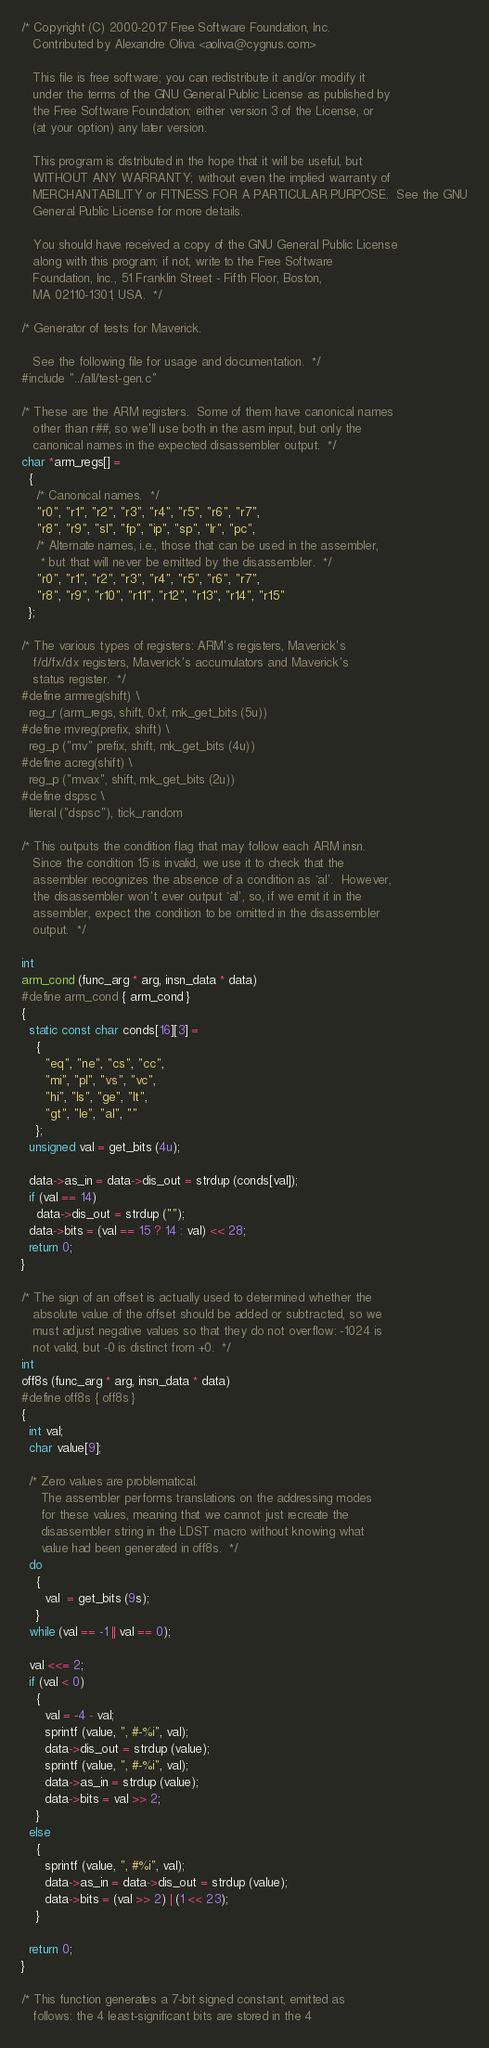Convert code to text. <code><loc_0><loc_0><loc_500><loc_500><_C_>/* Copyright (C) 2000-2017 Free Software Foundation, Inc.
   Contributed by Alexandre Oliva <aoliva@cygnus.com>

   This file is free software; you can redistribute it and/or modify it
   under the terms of the GNU General Public License as published by
   the Free Software Foundation; either version 3 of the License, or
   (at your option) any later version.

   This program is distributed in the hope that it will be useful, but
   WITHOUT ANY WARRANTY; without even the implied warranty of
   MERCHANTABILITY or FITNESS FOR A PARTICULAR PURPOSE.  See the GNU
   General Public License for more details.

   You should have received a copy of the GNU General Public License
   along with this program; if not, write to the Free Software
   Foundation, Inc., 51 Franklin Street - Fifth Floor, Boston,
   MA 02110-1301, USA.  */

/* Generator of tests for Maverick.

   See the following file for usage and documentation.  */
#include "../all/test-gen.c"

/* These are the ARM registers.  Some of them have canonical names
   other than r##, so we'll use both in the asm input, but only the
   canonical names in the expected disassembler output.  */
char *arm_regs[] =
  {
    /* Canonical names.  */
    "r0", "r1", "r2", "r3", "r4", "r5", "r6", "r7",
    "r8", "r9", "sl", "fp", "ip", "sp", "lr", "pc",
    /* Alternate names, i.e., those that can be used in the assembler,
     * but that will never be emitted by the disassembler.  */
    "r0", "r1", "r2", "r3", "r4", "r5", "r6", "r7",
    "r8", "r9", "r10", "r11", "r12", "r13", "r14", "r15"
  };

/* The various types of registers: ARM's registers, Maverick's
   f/d/fx/dx registers, Maverick's accumulators and Maverick's
   status register.  */
#define armreg(shift) \
  reg_r (arm_regs, shift, 0xf, mk_get_bits (5u))
#define mvreg(prefix, shift) \
  reg_p ("mv" prefix, shift, mk_get_bits (4u))
#define acreg(shift) \
  reg_p ("mvax", shift, mk_get_bits (2u))
#define dspsc \
  literal ("dspsc"), tick_random

/* This outputs the condition flag that may follow each ARM insn.
   Since the condition 15 is invalid, we use it to check that the
   assembler recognizes the absence of a condition as `al'.  However,
   the disassembler won't ever output `al', so, if we emit it in the
   assembler, expect the condition to be omitted in the disassembler
   output.  */

int
arm_cond (func_arg * arg, insn_data * data)
#define arm_cond { arm_cond }
{
  static const char conds[16][3] =
    {
      "eq", "ne", "cs", "cc",
      "mi", "pl", "vs", "vc",
      "hi", "ls", "ge", "lt",
      "gt", "le", "al", ""
    };
  unsigned val = get_bits (4u);

  data->as_in = data->dis_out = strdup (conds[val]);
  if (val == 14)
    data->dis_out = strdup ("");
  data->bits = (val == 15 ? 14 : val) << 28;
  return 0;
}

/* The sign of an offset is actually used to determined whether the
   absolute value of the offset should be added or subtracted, so we
   must adjust negative values so that they do not overflow: -1024 is
   not valid, but -0 is distinct from +0.  */
int
off8s (func_arg * arg, insn_data * data)
#define off8s { off8s }
{
  int val;
  char value[9];

  /* Zero values are problematical.
     The assembler performs translations on the addressing modes
     for these values, meaning that we cannot just recreate the
     disassembler string in the LDST macro without knowing what
     value had been generated in off8s.  */
  do
    {
      val  = get_bits (9s);
    }
  while (val == -1 || val == 0);
  
  val <<= 2;
  if (val < 0)
    {
      val = -4 - val;
      sprintf (value, ", #-%i", val);
      data->dis_out = strdup (value);
      sprintf (value, ", #-%i", val);
      data->as_in = strdup (value);
      data->bits = val >> 2;
    }
  else
    {
      sprintf (value, ", #%i", val);
      data->as_in = data->dis_out = strdup (value);
      data->bits = (val >> 2) | (1 << 23);
    }
  
  return 0;
}

/* This function generates a 7-bit signed constant, emitted as
   follows: the 4 least-significant bits are stored in the 4</code> 